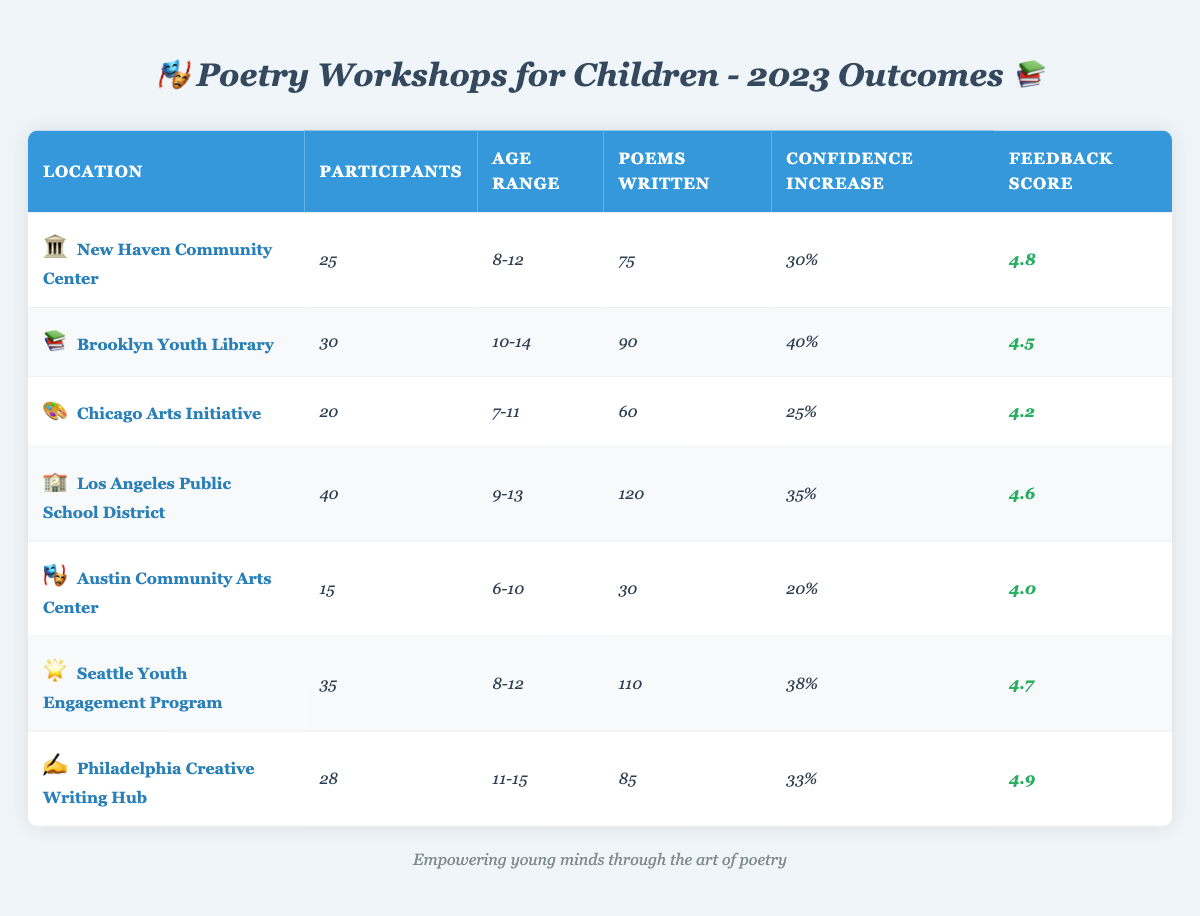What was the feedback score for the Brooklyn Youth Library workshop? The feedback score for the Brooklyn Youth Library workshop is specifically noted in the table under the "Feedback Score" column, which shows a value of 4.5.
Answer: 4.5 How many poems were written in total across all workshops? To find the total poems written, add the poems from each workshop: 75 + 90 + 60 + 120 + 30 + 110 + 85 = 570.
Answer: 570 Which workshop had the highest number of participants? By checking the "Participants" column in the table, the workshop with the highest number is "Los Angeles Public School District" with 40 participants.
Answer: Los Angeles Public School District Did the Seattle Youth Engagement Program have a higher feedback score than the Chicago Arts Initiative? Comparing the feedback scores, Seattle Youth Engagement Program has a score of 4.7 and Chicago Arts Initiative has 4.2. Since 4.7 is greater than 4.2, the answer is yes.
Answer: Yes What is the average confidence increase across all workshops? First, convert the percentage values into decimals: 0.30, 0.40, 0.25, 0.35, 0.20, 0.38, 0.33. Then, sum them up: 0.30 + 0.40 + 0.25 + 0.35 + 0.20 + 0.38 + 0.33 = 2.11. There are 7 workshops, so the average is 2.11 / 7 ≈ 0.3014 or approximately 30.14%.
Answer: 30.14% Which location had the lowest confidence increase, and what was that increase? The table shows that the Austin Community Arts Center had a confidence increase of 20%, which is the lowest among all listed workshops.
Answer: Austin Community Arts Center, 20% Out of the workshops, which one had the highest feedback score and what was it? The feedback scores are compared, and Philadelphia Creative Writing Hub has the highest score at 4.9 according to the "Feedback Score" column.
Answer: Philadelphia Creative Writing Hub, 4.9 What is the age range of participants at the New Haven Community Center workshop? The age range for the New Haven Community Center is specifically indicated as 8-12 years in the "Age Range" column of the table.
Answer: 8-12 How many more poems were written in Los Angeles Public School District compared to the Chicago Arts Initiative? The poems written for Los Angeles Public School District is 120 and for Chicago Arts Initiative is 60. Subtracting these gives 120 - 60 = 60 more poems written in Los Angeles.
Answer: 60 Is the average number of participants at the workshops greater than 30? Calculate the average by summing the participants: 25 + 30 + 20 + 40 + 15 + 35 + 28 = 193. The average is 193 / 7 ≈ 27.57, which is less than 30. So, the answer is no.
Answer: No Which workshop had the least number of poems written, and what was that number? The least number of poems written is seen in the Austin Community Arts Center with 30 poems in the "Poems Written" column.
Answer: Austin Community Arts Center, 30 